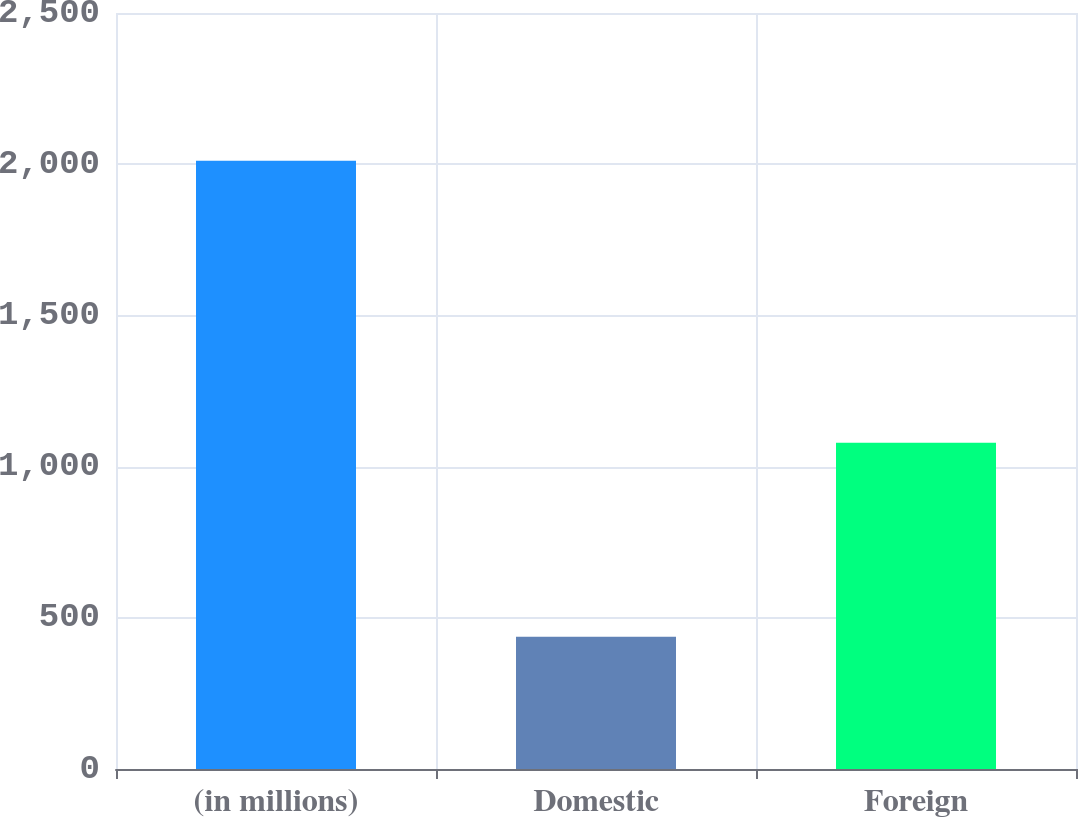Convert chart to OTSL. <chart><loc_0><loc_0><loc_500><loc_500><bar_chart><fcel>(in millions)<fcel>Domestic<fcel>Foreign<nl><fcel>2011<fcel>437<fcel>1079<nl></chart> 